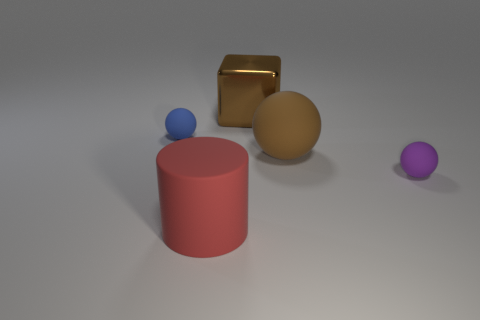There is a big brown matte thing; is it the same shape as the large brown object that is behind the blue rubber ball?
Ensure brevity in your answer.  No. There is a matte thing that is left of the large brown metallic block and in front of the large brown ball; what size is it?
Your response must be concise. Large. The large metallic object is what shape?
Keep it short and to the point. Cube. There is a small thing that is on the right side of the red thing; is there a brown metal cube that is left of it?
Give a very brief answer. Yes. How many big matte cylinders are in front of the large matte object on the right side of the cylinder?
Offer a very short reply. 1. There is a brown block that is the same size as the brown matte thing; what material is it?
Make the answer very short. Metal. There is a tiny object on the right side of the rubber cylinder; does it have the same shape as the big metallic object?
Offer a terse response. No. Are there more rubber objects that are to the right of the large brown matte sphere than red rubber cylinders behind the blue sphere?
Keep it short and to the point. Yes. How many objects have the same material as the large cylinder?
Keep it short and to the point. 3. Does the red cylinder have the same size as the shiny thing?
Offer a very short reply. Yes. 